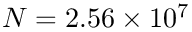Convert formula to latex. <formula><loc_0><loc_0><loc_500><loc_500>N = 2 . 5 6 \times 1 0 ^ { 7 }</formula> 